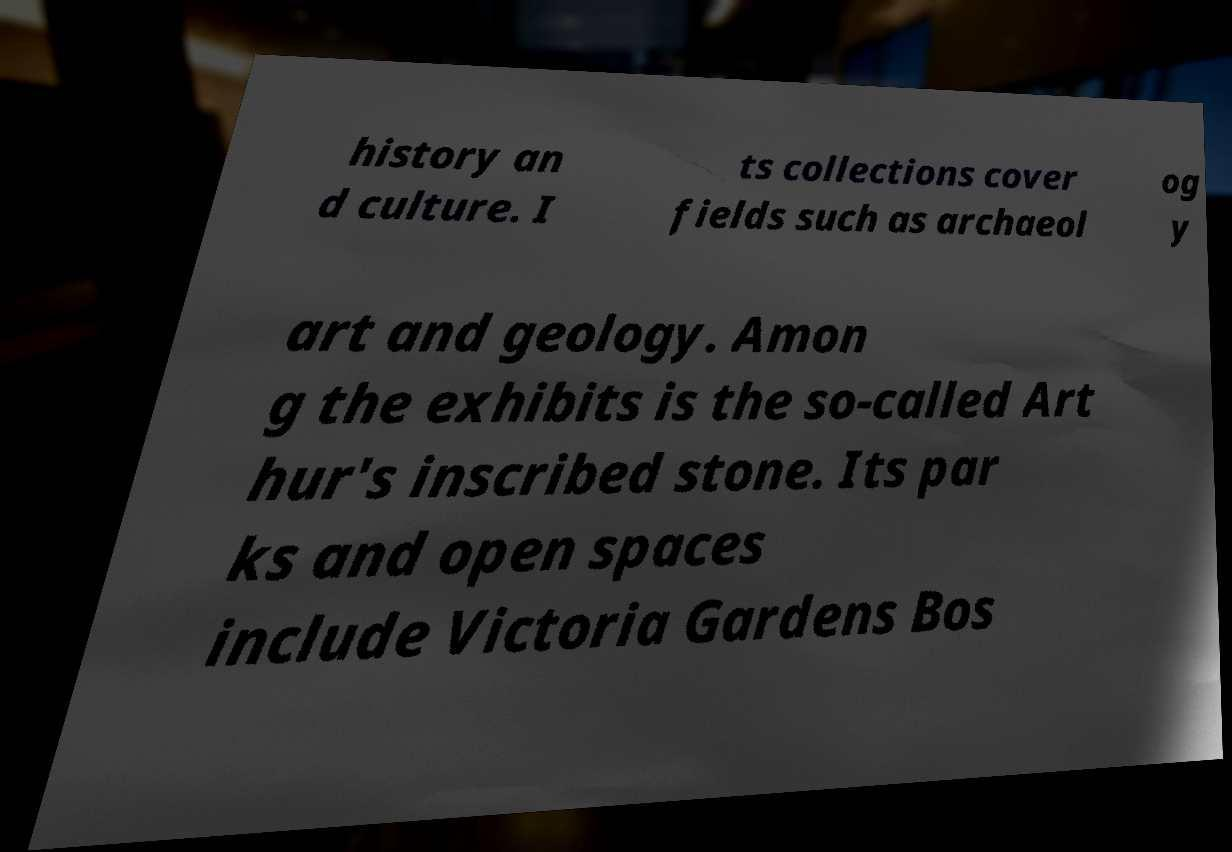What messages or text are displayed in this image? I need them in a readable, typed format. history an d culture. I ts collections cover fields such as archaeol og y art and geology. Amon g the exhibits is the so-called Art hur's inscribed stone. Its par ks and open spaces include Victoria Gardens Bos 